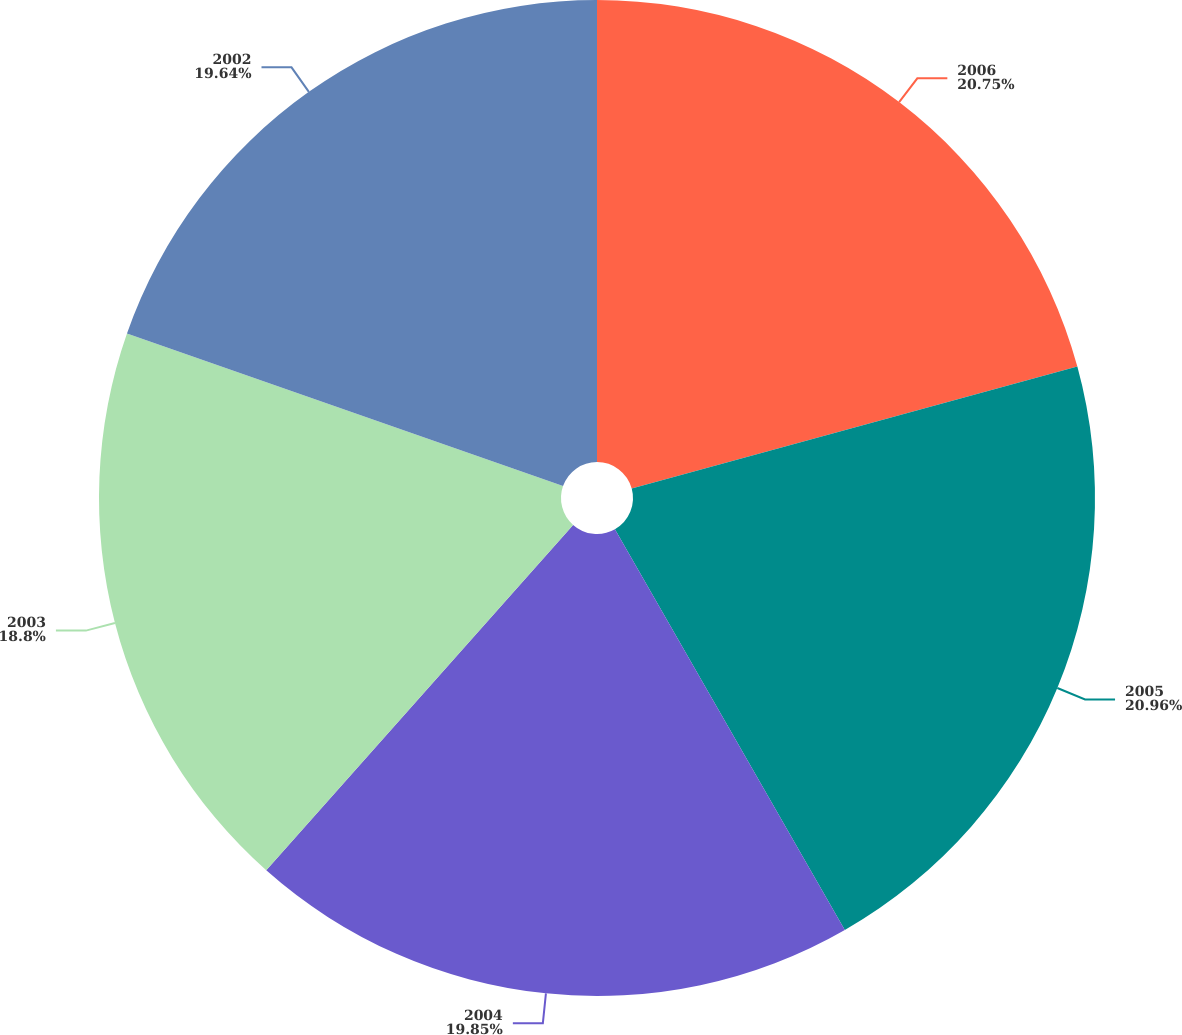Convert chart to OTSL. <chart><loc_0><loc_0><loc_500><loc_500><pie_chart><fcel>2006<fcel>2005<fcel>2004<fcel>2003<fcel>2002<nl><fcel>20.75%<fcel>20.96%<fcel>19.85%<fcel>18.8%<fcel>19.64%<nl></chart> 